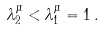<formula> <loc_0><loc_0><loc_500><loc_500>\lambda ^ { \mu } _ { 2 } < \lambda ^ { \mu } _ { 1 } = 1 \, .</formula> 